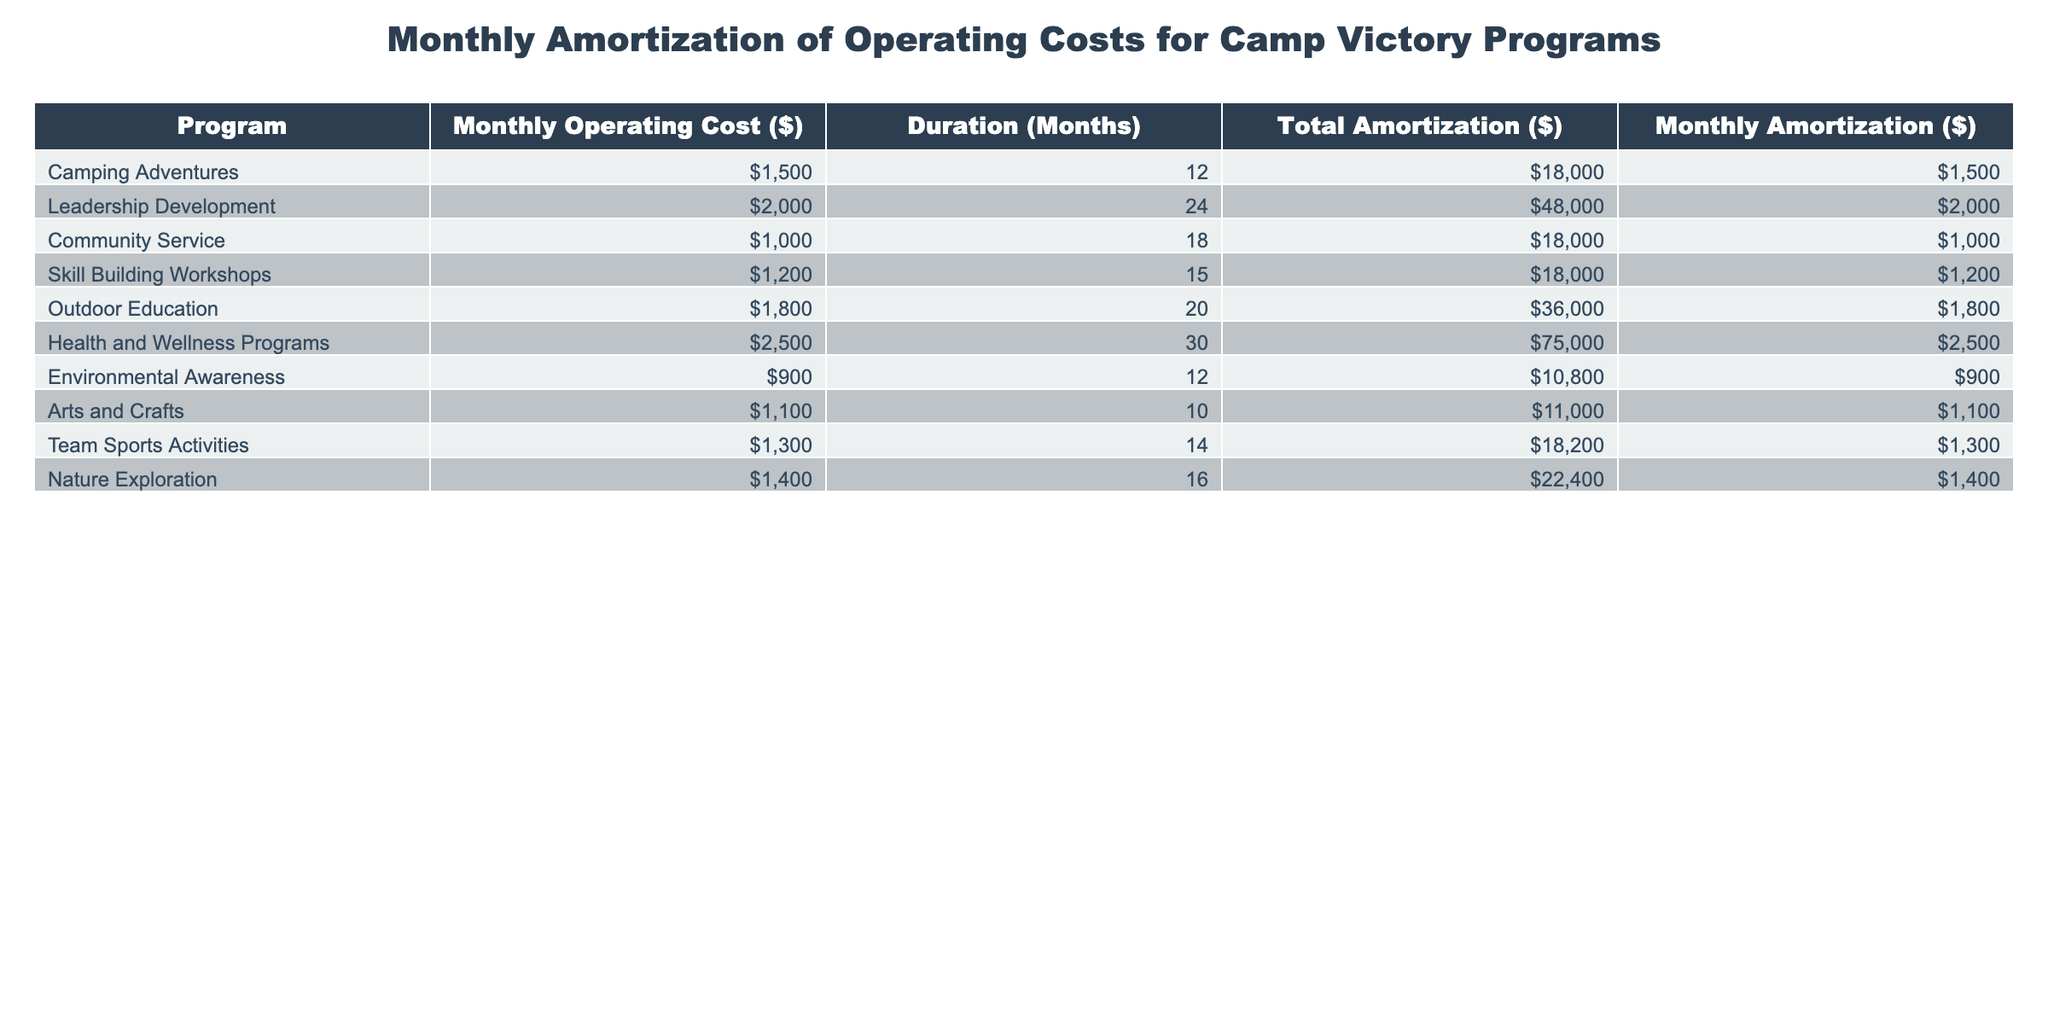What is the monthly operating cost for the Health and Wellness Programs? The monthly operating cost for each program is listed in the second column of the table. For the Health and Wellness Programs, the corresponding value is 2500.
Answer: 2500 Which program has the longest duration of amortization? The duration of amortization is found in the third column. By scanning through this column, the Leadership Development program has the longest duration of 24 months.
Answer: Leadership Development What is the total amortization for Community Service? The total amortization values are in the fourth column. For Community Service, the total amortization is 18000, as listed in that row.
Answer: 18000 How much more is the monthly amortization of Health and Wellness Programs compared to Outdoor Education? The monthly amortization values are in the fifth column. The Health and Wellness Programs amount to 2500 and the Outdoor Education is 1800. The difference is calculated as 2500 - 1800 = 700.
Answer: 700 Is the monthly operating cost for Nature Exploration greater than the average monthly operating cost of all programs? First, we find the monthly operating cost for Nature Exploration, which is 1400. Next, we calculate the average monthly operating cost by summing all monthly costs (1500 + 2000 + 1000 + 1200 + 1800 + 2500 + 900 + 1100 + 1300 + 1400 = 13900) and dividing by the number of programs (10). The average is 1390. Since 1400 is greater than 1390, the answer is yes.
Answer: Yes What is the total amortization for all programs combined? To find the total amortization for all programs, we sum all values in the fourth column: 18000 + 48000 + 18000 + 18000 + 36000 + 75000 + 10800 + 11000 + 18200 + 22400 = 207400.
Answer: 207400 